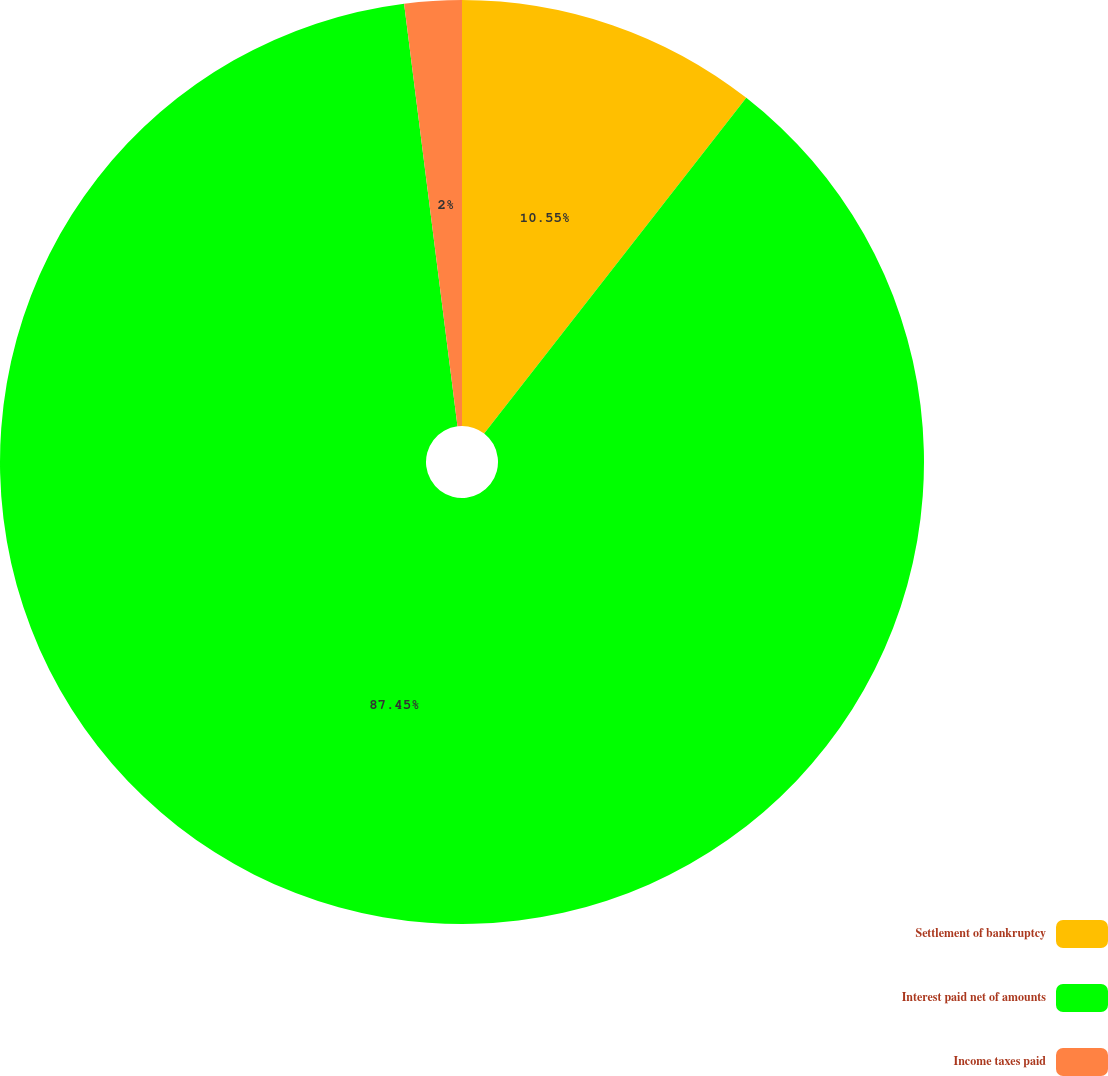Convert chart to OTSL. <chart><loc_0><loc_0><loc_500><loc_500><pie_chart><fcel>Settlement of bankruptcy<fcel>Interest paid net of amounts<fcel>Income taxes paid<nl><fcel>10.55%<fcel>87.45%<fcel>2.0%<nl></chart> 